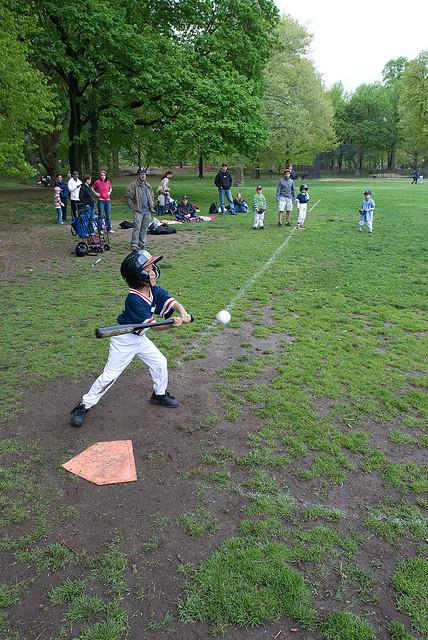Has the child hit the baseball yet?
Answer briefly. No. What will happen to the ball?
Keep it brief. Get hit. What color is the baseball?
Be succinct. White. 